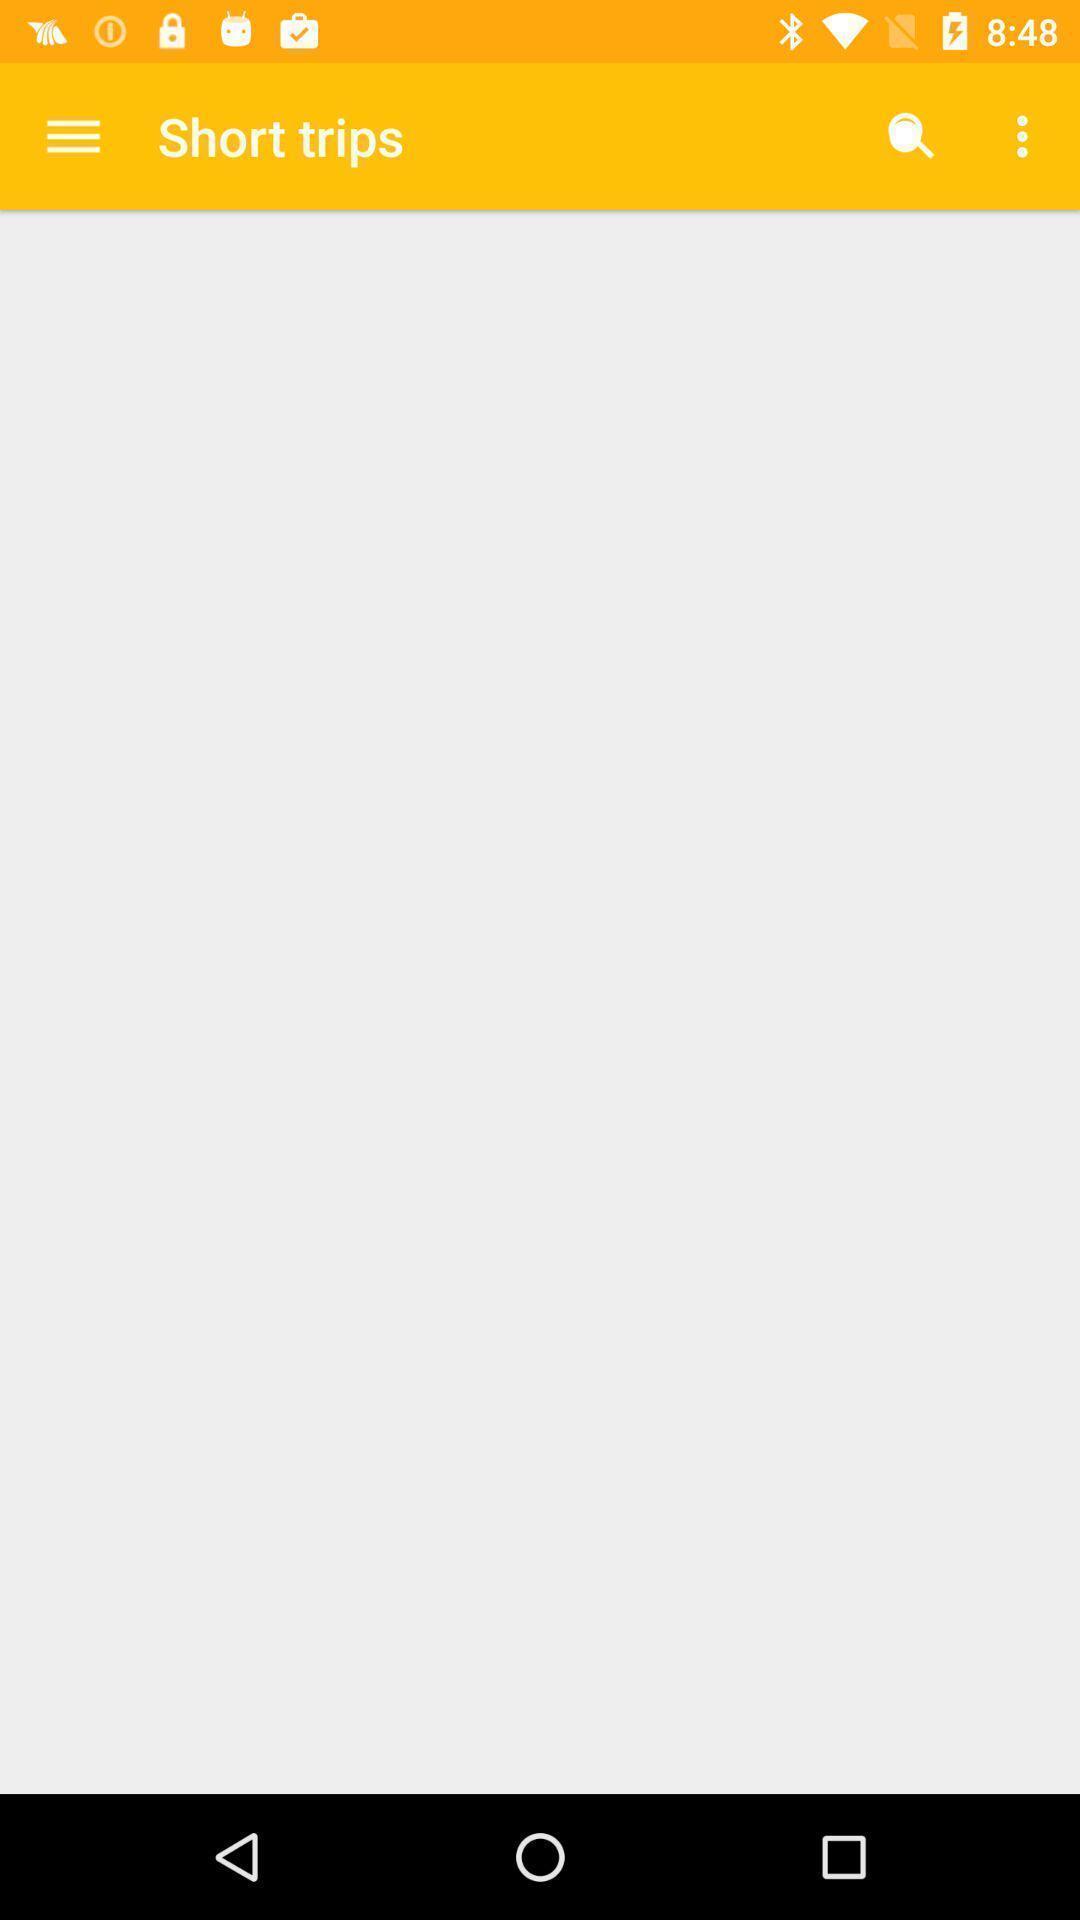Summarize the main components in this picture. Page of a travel app. 